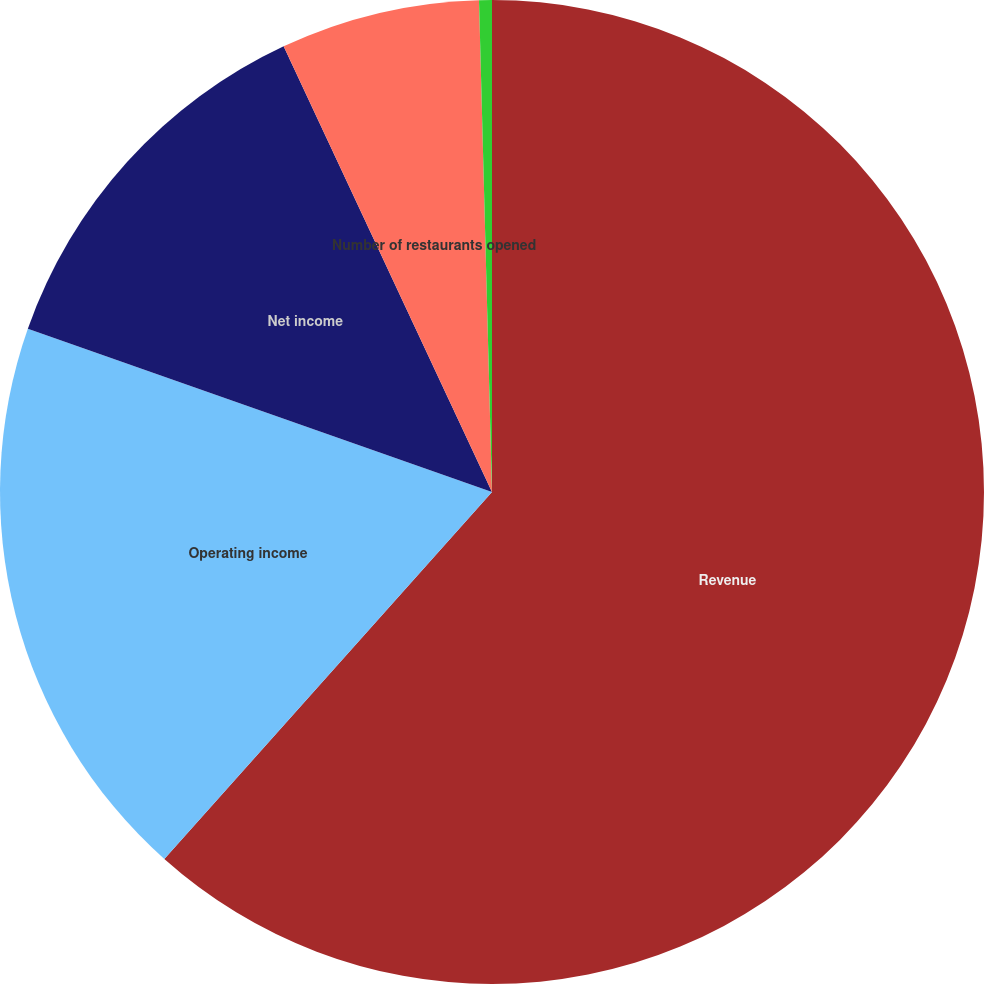Convert chart to OTSL. <chart><loc_0><loc_0><loc_500><loc_500><pie_chart><fcel>Revenue<fcel>Operating income<fcel>Net income<fcel>Number of restaurants opened<fcel>Comparable restaurant sales<nl><fcel>61.6%<fcel>18.78%<fcel>12.66%<fcel>6.54%<fcel>0.42%<nl></chart> 